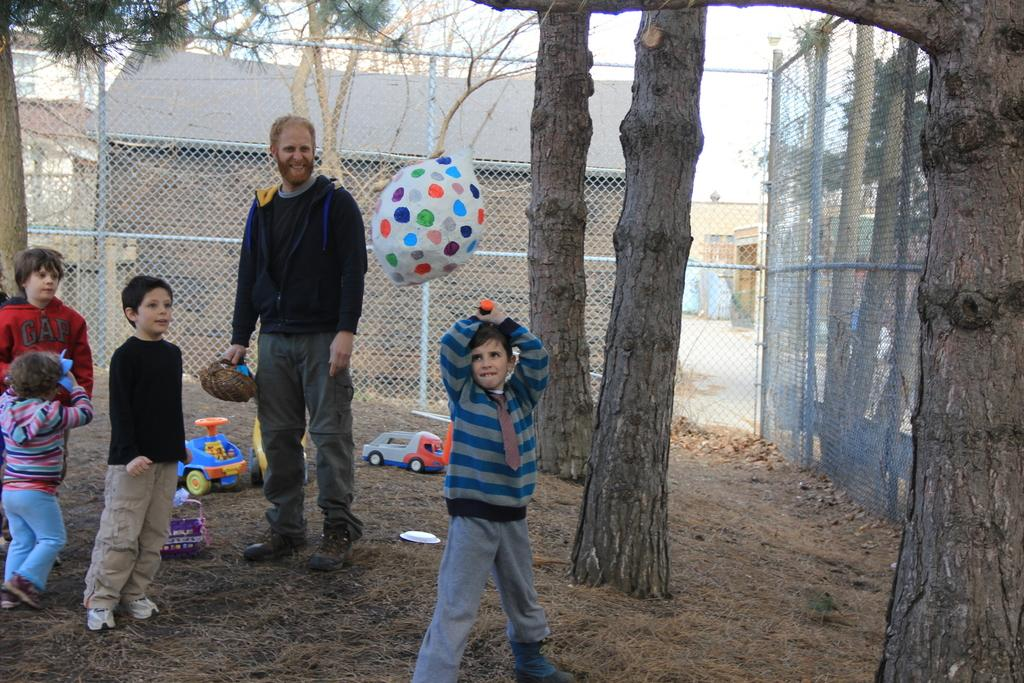How many people are in the image? There is a group of people in the image, but the exact number cannot be determined from the provided facts. What are the people in the image doing? The people are on the ground in the image. What can be seen in the background of the image? There is a fence and trees in the background of the image. What type of crack is visible on the rifle in the image? There is no rifle present in the image, so it is not possible to answer that question. 